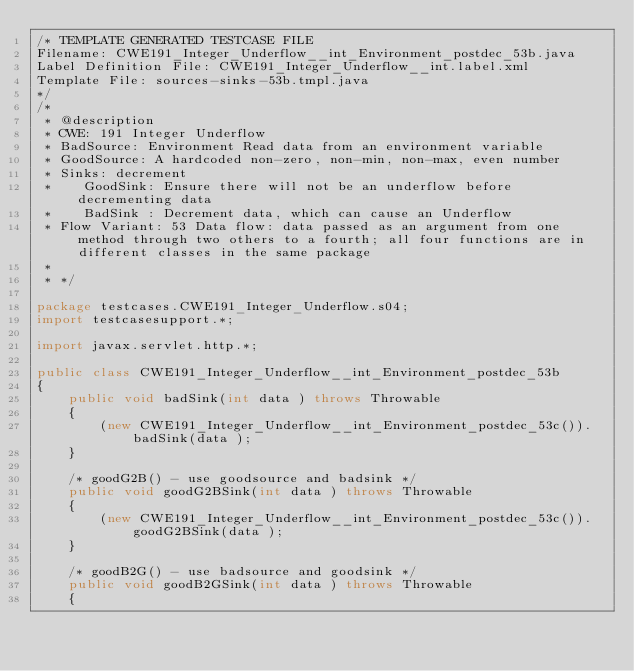Convert code to text. <code><loc_0><loc_0><loc_500><loc_500><_Java_>/* TEMPLATE GENERATED TESTCASE FILE
Filename: CWE191_Integer_Underflow__int_Environment_postdec_53b.java
Label Definition File: CWE191_Integer_Underflow__int.label.xml
Template File: sources-sinks-53b.tmpl.java
*/
/*
 * @description
 * CWE: 191 Integer Underflow
 * BadSource: Environment Read data from an environment variable
 * GoodSource: A hardcoded non-zero, non-min, non-max, even number
 * Sinks: decrement
 *    GoodSink: Ensure there will not be an underflow before decrementing data
 *    BadSink : Decrement data, which can cause an Underflow
 * Flow Variant: 53 Data flow: data passed as an argument from one method through two others to a fourth; all four functions are in different classes in the same package
 *
 * */

package testcases.CWE191_Integer_Underflow.s04;
import testcasesupport.*;

import javax.servlet.http.*;

public class CWE191_Integer_Underflow__int_Environment_postdec_53b
{
    public void badSink(int data ) throws Throwable
    {
        (new CWE191_Integer_Underflow__int_Environment_postdec_53c()).badSink(data );
    }

    /* goodG2B() - use goodsource and badsink */
    public void goodG2BSink(int data ) throws Throwable
    {
        (new CWE191_Integer_Underflow__int_Environment_postdec_53c()).goodG2BSink(data );
    }

    /* goodB2G() - use badsource and goodsink */
    public void goodB2GSink(int data ) throws Throwable
    {</code> 